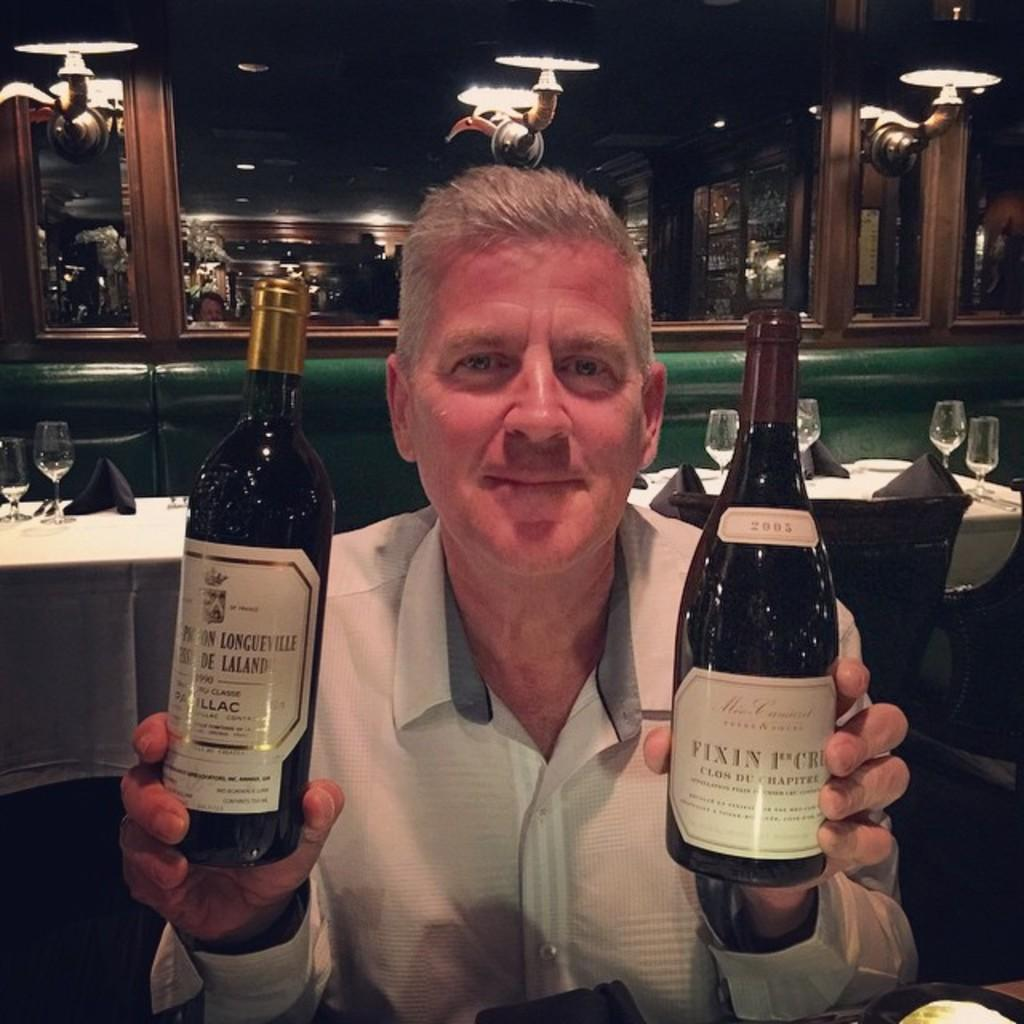<image>
Give a short and clear explanation of the subsequent image. A man holds two bottles of wine, one of which says Fixin. 